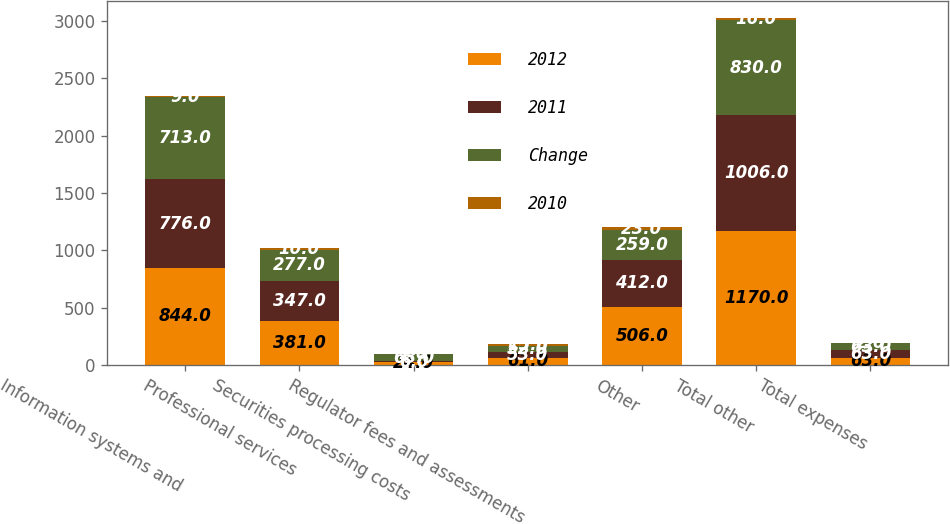Convert chart to OTSL. <chart><loc_0><loc_0><loc_500><loc_500><stacked_bar_chart><ecel><fcel>Information systems and<fcel>Professional services<fcel>Securities processing costs<fcel>Regulator fees and assessments<fcel>Other<fcel>Total other<fcel>Total expenses<nl><fcel>2012<fcel>844<fcel>381<fcel>24<fcel>61<fcel>506<fcel>1170<fcel>63<nl><fcel>2011<fcel>776<fcel>347<fcel>6<fcel>53<fcel>412<fcel>1006<fcel>63<nl><fcel>Change<fcel>713<fcel>277<fcel>63<fcel>52<fcel>259<fcel>830<fcel>63<nl><fcel>2010<fcel>9<fcel>10<fcel>1<fcel>15<fcel>23<fcel>16<fcel>2<nl></chart> 